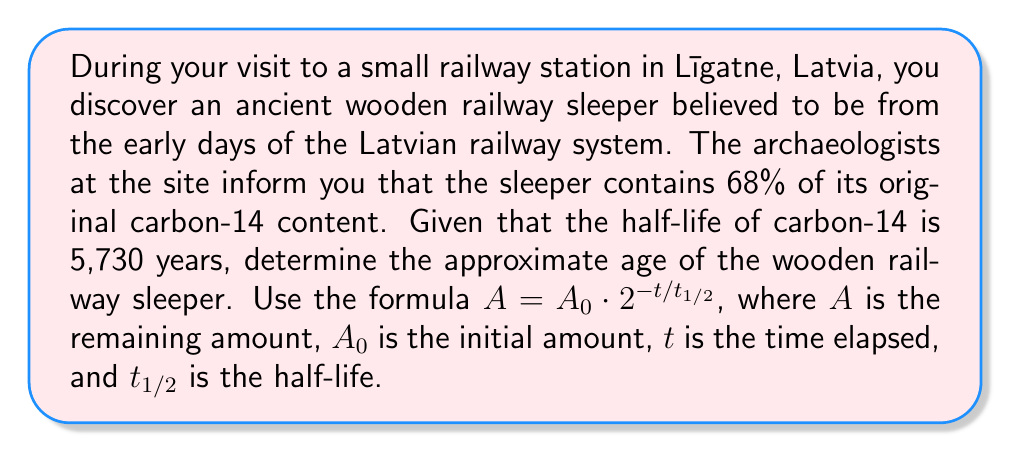Teach me how to tackle this problem. Let's approach this problem step-by-step using logarithms:

1) We start with the given formula: $A = A_0 \cdot 2^{-t/t_{1/2}}$

2) We know that $A/A_0 = 0.68$ (68% of the original content remains)

3) Substituting this into our equation:
   $0.68 = 2^{-t/5730}$

4) To solve for $t$, we need to use logarithms. Let's apply $\log_2$ to both sides:
   $\log_2(0.68) = \log_2(2^{-t/5730})$

5) Using the logarithm property $\log_a(x^n) = n\log_a(x)$:
   $\log_2(0.68) = -t/5730 \cdot \log_2(2)$

6) Since $\log_2(2) = 1$, our equation simplifies to:
   $\log_2(0.68) = -t/5730$

7) Solving for $t$:
   $t = -5730 \cdot \log_2(0.68)$

8) We can change the base of the logarithm using the change of base formula:
   $t = -5730 \cdot \frac{\ln(0.68)}{\ln(2)}$

9) Calculating this:
   $t \approx 3052.7$ years

Therefore, the wooden railway sleeper is approximately 3,053 years old.
Answer: The wooden railway sleeper is approximately 3,053 years old. 